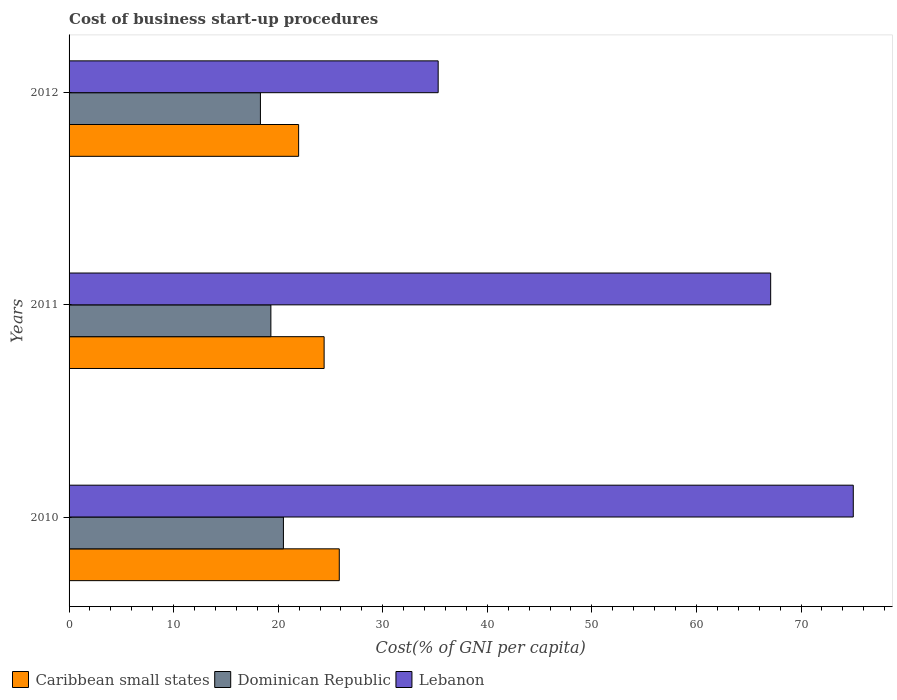What is the cost of business start-up procedures in Lebanon in 2010?
Your answer should be very brief. 75. Across all years, what is the maximum cost of business start-up procedures in Caribbean small states?
Provide a short and direct response. 25.84. Across all years, what is the minimum cost of business start-up procedures in Dominican Republic?
Provide a succinct answer. 18.3. In which year was the cost of business start-up procedures in Lebanon maximum?
Your response must be concise. 2010. What is the total cost of business start-up procedures in Lebanon in the graph?
Your response must be concise. 177.4. What is the difference between the cost of business start-up procedures in Dominican Republic in 2010 and that in 2011?
Offer a very short reply. 1.2. What is the difference between the cost of business start-up procedures in Caribbean small states in 2011 and the cost of business start-up procedures in Dominican Republic in 2012?
Provide a short and direct response. 6.09. What is the average cost of business start-up procedures in Lebanon per year?
Make the answer very short. 59.13. In the year 2011, what is the difference between the cost of business start-up procedures in Caribbean small states and cost of business start-up procedures in Lebanon?
Provide a succinct answer. -42.71. In how many years, is the cost of business start-up procedures in Caribbean small states greater than 12 %?
Provide a short and direct response. 3. What is the ratio of the cost of business start-up procedures in Caribbean small states in 2010 to that in 2011?
Provide a short and direct response. 1.06. What is the difference between the highest and the second highest cost of business start-up procedures in Caribbean small states?
Give a very brief answer. 1.45. What is the difference between the highest and the lowest cost of business start-up procedures in Lebanon?
Offer a very short reply. 39.7. In how many years, is the cost of business start-up procedures in Lebanon greater than the average cost of business start-up procedures in Lebanon taken over all years?
Keep it short and to the point. 2. What does the 3rd bar from the top in 2012 represents?
Give a very brief answer. Caribbean small states. What does the 2nd bar from the bottom in 2010 represents?
Give a very brief answer. Dominican Republic. Is it the case that in every year, the sum of the cost of business start-up procedures in Dominican Republic and cost of business start-up procedures in Caribbean small states is greater than the cost of business start-up procedures in Lebanon?
Make the answer very short. No. How many bars are there?
Provide a succinct answer. 9. How many years are there in the graph?
Provide a short and direct response. 3. What is the difference between two consecutive major ticks on the X-axis?
Offer a terse response. 10. Does the graph contain any zero values?
Keep it short and to the point. No. Does the graph contain grids?
Your answer should be compact. No. Where does the legend appear in the graph?
Your answer should be very brief. Bottom left. How many legend labels are there?
Ensure brevity in your answer.  3. What is the title of the graph?
Ensure brevity in your answer.  Cost of business start-up procedures. Does "Kyrgyz Republic" appear as one of the legend labels in the graph?
Ensure brevity in your answer.  No. What is the label or title of the X-axis?
Ensure brevity in your answer.  Cost(% of GNI per capita). What is the label or title of the Y-axis?
Provide a short and direct response. Years. What is the Cost(% of GNI per capita) of Caribbean small states in 2010?
Make the answer very short. 25.84. What is the Cost(% of GNI per capita) of Dominican Republic in 2010?
Your answer should be compact. 20.5. What is the Cost(% of GNI per capita) of Lebanon in 2010?
Give a very brief answer. 75. What is the Cost(% of GNI per capita) of Caribbean small states in 2011?
Keep it short and to the point. 24.39. What is the Cost(% of GNI per capita) in Dominican Republic in 2011?
Offer a very short reply. 19.3. What is the Cost(% of GNI per capita) of Lebanon in 2011?
Provide a short and direct response. 67.1. What is the Cost(% of GNI per capita) of Caribbean small states in 2012?
Ensure brevity in your answer.  21.95. What is the Cost(% of GNI per capita) in Dominican Republic in 2012?
Your answer should be very brief. 18.3. What is the Cost(% of GNI per capita) of Lebanon in 2012?
Keep it short and to the point. 35.3. Across all years, what is the maximum Cost(% of GNI per capita) of Caribbean small states?
Provide a short and direct response. 25.84. Across all years, what is the maximum Cost(% of GNI per capita) of Dominican Republic?
Your answer should be compact. 20.5. Across all years, what is the minimum Cost(% of GNI per capita) of Caribbean small states?
Offer a terse response. 21.95. Across all years, what is the minimum Cost(% of GNI per capita) of Lebanon?
Keep it short and to the point. 35.3. What is the total Cost(% of GNI per capita) in Caribbean small states in the graph?
Ensure brevity in your answer.  72.19. What is the total Cost(% of GNI per capita) of Dominican Republic in the graph?
Your answer should be compact. 58.1. What is the total Cost(% of GNI per capita) in Lebanon in the graph?
Keep it short and to the point. 177.4. What is the difference between the Cost(% of GNI per capita) in Caribbean small states in 2010 and that in 2011?
Provide a succinct answer. 1.45. What is the difference between the Cost(% of GNI per capita) in Dominican Republic in 2010 and that in 2011?
Your answer should be compact. 1.2. What is the difference between the Cost(% of GNI per capita) of Caribbean small states in 2010 and that in 2012?
Your answer should be compact. 3.89. What is the difference between the Cost(% of GNI per capita) of Lebanon in 2010 and that in 2012?
Make the answer very short. 39.7. What is the difference between the Cost(% of GNI per capita) of Caribbean small states in 2011 and that in 2012?
Ensure brevity in your answer.  2.44. What is the difference between the Cost(% of GNI per capita) of Dominican Republic in 2011 and that in 2012?
Provide a succinct answer. 1. What is the difference between the Cost(% of GNI per capita) of Lebanon in 2011 and that in 2012?
Offer a very short reply. 31.8. What is the difference between the Cost(% of GNI per capita) of Caribbean small states in 2010 and the Cost(% of GNI per capita) of Dominican Republic in 2011?
Your answer should be compact. 6.54. What is the difference between the Cost(% of GNI per capita) of Caribbean small states in 2010 and the Cost(% of GNI per capita) of Lebanon in 2011?
Offer a terse response. -41.26. What is the difference between the Cost(% of GNI per capita) in Dominican Republic in 2010 and the Cost(% of GNI per capita) in Lebanon in 2011?
Ensure brevity in your answer.  -46.6. What is the difference between the Cost(% of GNI per capita) in Caribbean small states in 2010 and the Cost(% of GNI per capita) in Dominican Republic in 2012?
Your response must be concise. 7.54. What is the difference between the Cost(% of GNI per capita) of Caribbean small states in 2010 and the Cost(% of GNI per capita) of Lebanon in 2012?
Keep it short and to the point. -9.46. What is the difference between the Cost(% of GNI per capita) in Dominican Republic in 2010 and the Cost(% of GNI per capita) in Lebanon in 2012?
Your answer should be very brief. -14.8. What is the difference between the Cost(% of GNI per capita) of Caribbean small states in 2011 and the Cost(% of GNI per capita) of Dominican Republic in 2012?
Make the answer very short. 6.09. What is the difference between the Cost(% of GNI per capita) in Caribbean small states in 2011 and the Cost(% of GNI per capita) in Lebanon in 2012?
Your answer should be very brief. -10.91. What is the average Cost(% of GNI per capita) in Caribbean small states per year?
Provide a succinct answer. 24.06. What is the average Cost(% of GNI per capita) of Dominican Republic per year?
Offer a very short reply. 19.37. What is the average Cost(% of GNI per capita) of Lebanon per year?
Offer a very short reply. 59.13. In the year 2010, what is the difference between the Cost(% of GNI per capita) in Caribbean small states and Cost(% of GNI per capita) in Dominican Republic?
Your answer should be compact. 5.34. In the year 2010, what is the difference between the Cost(% of GNI per capita) of Caribbean small states and Cost(% of GNI per capita) of Lebanon?
Make the answer very short. -49.16. In the year 2010, what is the difference between the Cost(% of GNI per capita) in Dominican Republic and Cost(% of GNI per capita) in Lebanon?
Your answer should be compact. -54.5. In the year 2011, what is the difference between the Cost(% of GNI per capita) in Caribbean small states and Cost(% of GNI per capita) in Dominican Republic?
Provide a succinct answer. 5.09. In the year 2011, what is the difference between the Cost(% of GNI per capita) in Caribbean small states and Cost(% of GNI per capita) in Lebanon?
Make the answer very short. -42.71. In the year 2011, what is the difference between the Cost(% of GNI per capita) in Dominican Republic and Cost(% of GNI per capita) in Lebanon?
Offer a terse response. -47.8. In the year 2012, what is the difference between the Cost(% of GNI per capita) of Caribbean small states and Cost(% of GNI per capita) of Dominican Republic?
Give a very brief answer. 3.65. In the year 2012, what is the difference between the Cost(% of GNI per capita) of Caribbean small states and Cost(% of GNI per capita) of Lebanon?
Your answer should be very brief. -13.35. In the year 2012, what is the difference between the Cost(% of GNI per capita) of Dominican Republic and Cost(% of GNI per capita) of Lebanon?
Your answer should be compact. -17. What is the ratio of the Cost(% of GNI per capita) in Caribbean small states in 2010 to that in 2011?
Give a very brief answer. 1.06. What is the ratio of the Cost(% of GNI per capita) of Dominican Republic in 2010 to that in 2011?
Your response must be concise. 1.06. What is the ratio of the Cost(% of GNI per capita) of Lebanon in 2010 to that in 2011?
Provide a succinct answer. 1.12. What is the ratio of the Cost(% of GNI per capita) in Caribbean small states in 2010 to that in 2012?
Provide a succinct answer. 1.18. What is the ratio of the Cost(% of GNI per capita) of Dominican Republic in 2010 to that in 2012?
Give a very brief answer. 1.12. What is the ratio of the Cost(% of GNI per capita) in Lebanon in 2010 to that in 2012?
Give a very brief answer. 2.12. What is the ratio of the Cost(% of GNI per capita) of Caribbean small states in 2011 to that in 2012?
Offer a very short reply. 1.11. What is the ratio of the Cost(% of GNI per capita) in Dominican Republic in 2011 to that in 2012?
Your response must be concise. 1.05. What is the ratio of the Cost(% of GNI per capita) in Lebanon in 2011 to that in 2012?
Ensure brevity in your answer.  1.9. What is the difference between the highest and the second highest Cost(% of GNI per capita) in Caribbean small states?
Your response must be concise. 1.45. What is the difference between the highest and the second highest Cost(% of GNI per capita) of Lebanon?
Provide a succinct answer. 7.9. What is the difference between the highest and the lowest Cost(% of GNI per capita) of Caribbean small states?
Your answer should be compact. 3.89. What is the difference between the highest and the lowest Cost(% of GNI per capita) of Dominican Republic?
Offer a terse response. 2.2. What is the difference between the highest and the lowest Cost(% of GNI per capita) of Lebanon?
Keep it short and to the point. 39.7. 